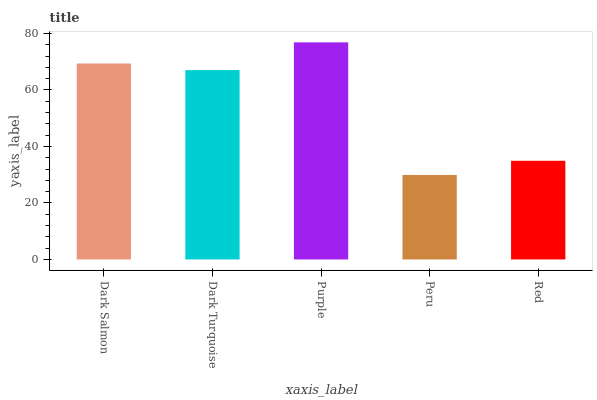Is Peru the minimum?
Answer yes or no. Yes. Is Purple the maximum?
Answer yes or no. Yes. Is Dark Turquoise the minimum?
Answer yes or no. No. Is Dark Turquoise the maximum?
Answer yes or no. No. Is Dark Salmon greater than Dark Turquoise?
Answer yes or no. Yes. Is Dark Turquoise less than Dark Salmon?
Answer yes or no. Yes. Is Dark Turquoise greater than Dark Salmon?
Answer yes or no. No. Is Dark Salmon less than Dark Turquoise?
Answer yes or no. No. Is Dark Turquoise the high median?
Answer yes or no. Yes. Is Dark Turquoise the low median?
Answer yes or no. Yes. Is Dark Salmon the high median?
Answer yes or no. No. Is Peru the low median?
Answer yes or no. No. 